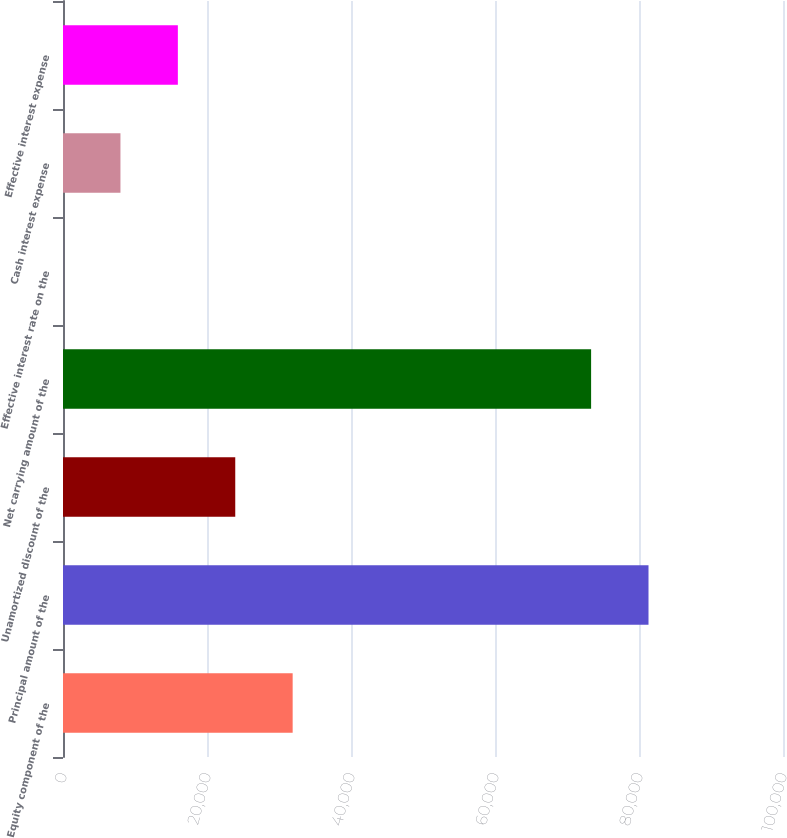Convert chart. <chart><loc_0><loc_0><loc_500><loc_500><bar_chart><fcel>Equity component of the<fcel>Principal amount of the<fcel>Unamortized discount of the<fcel>Net carrying amount of the<fcel>Effective interest rate on the<fcel>Cash interest expense<fcel>Effective interest expense<nl><fcel>31897.3<fcel>81320.6<fcel>23924.7<fcel>73348<fcel>6.86<fcel>7979.47<fcel>15952.1<nl></chart> 